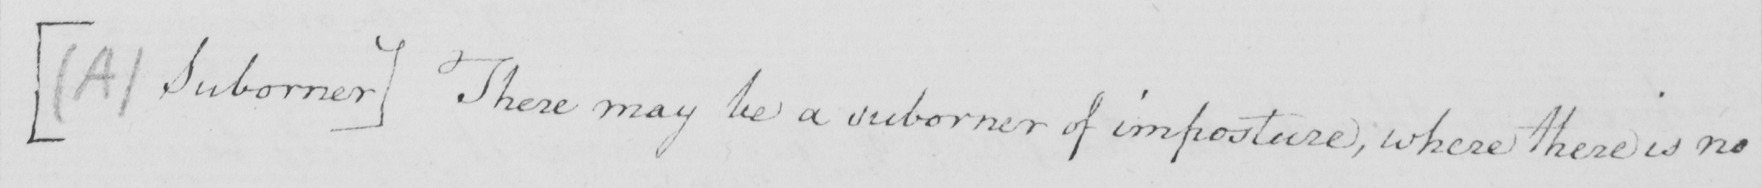What text is written in this handwritten line? [  ( A )  Suborner ]  There may be a suborner of imposture , where there is no 